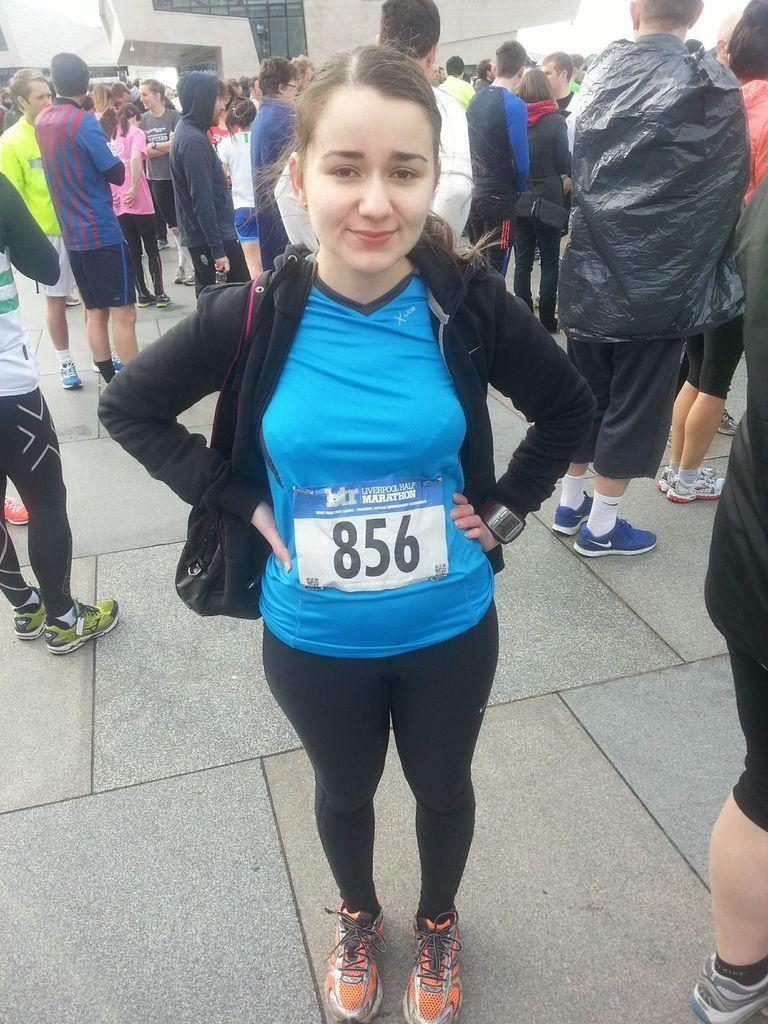Who is the main subject in the image? There is a woman in the image. What is the woman wearing? The woman is wearing a blue and black dress. Where is the woman located in the image? The woman is standing on the ground. What can be seen in the background of the image? There are other persons standing in the background of the image, and there is a building visible as well. What type of blade can be seen in the woman's hand in the image? There is no blade present in the woman's hand or anywhere in the image. Can you tell me how many fish are swimming in the background of the image? There are no fish present in the image; the background features other persons and a building. 